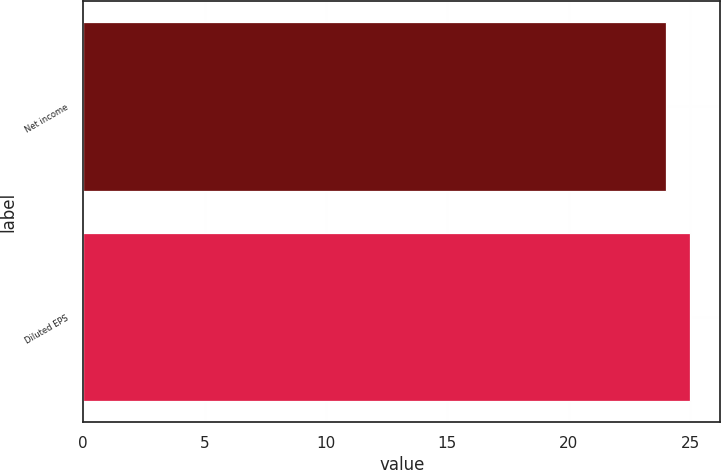Convert chart. <chart><loc_0><loc_0><loc_500><loc_500><bar_chart><fcel>Net income<fcel>Diluted EPS<nl><fcel>24<fcel>25<nl></chart> 